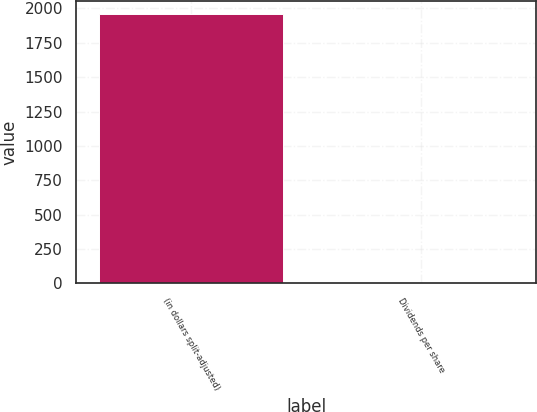<chart> <loc_0><loc_0><loc_500><loc_500><bar_chart><fcel>(in dollars split-adjusted)<fcel>Dividends per share<nl><fcel>1959<fcel>0.02<nl></chart> 